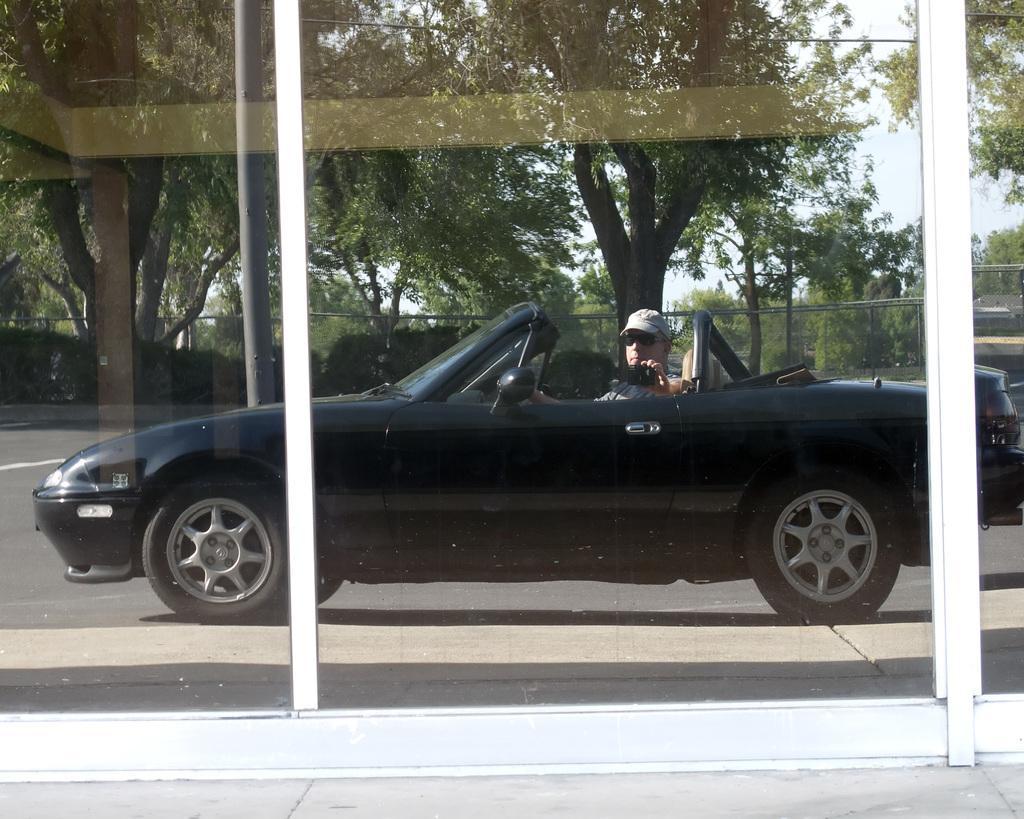How would you summarize this image in a sentence or two? In this picture we can see a person is sitting in the car and he is holding an object, in the background we can see few trees and fence. 